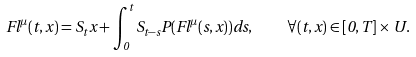Convert formula to latex. <formula><loc_0><loc_0><loc_500><loc_500>F l ^ { \mu } ( t , x ) = S _ { t } x + \int _ { 0 } ^ { t } S _ { t - s } P ( F l ^ { \mu } ( s , x ) ) d s , \quad \forall ( t , x ) \in [ 0 , T ] \times U .</formula> 